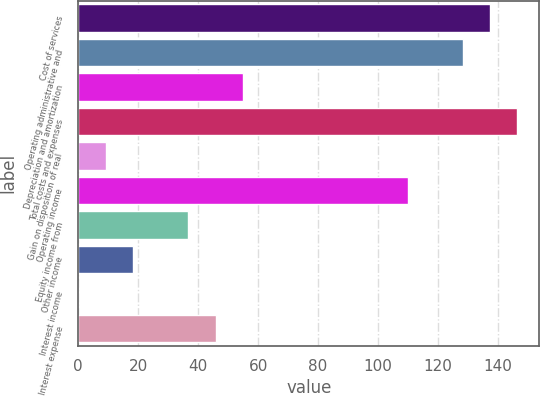Convert chart. <chart><loc_0><loc_0><loc_500><loc_500><bar_chart><fcel>Cost of services<fcel>Operating administrative and<fcel>Depreciation and amortization<fcel>Total costs and expenses<fcel>Gain on disposition of real<fcel>Operating income<fcel>Equity income from<fcel>Other income<fcel>Interest income<fcel>Interest expense<nl><fcel>137.35<fcel>128.2<fcel>55<fcel>146.5<fcel>9.25<fcel>109.9<fcel>36.7<fcel>18.4<fcel>0.1<fcel>45.85<nl></chart> 